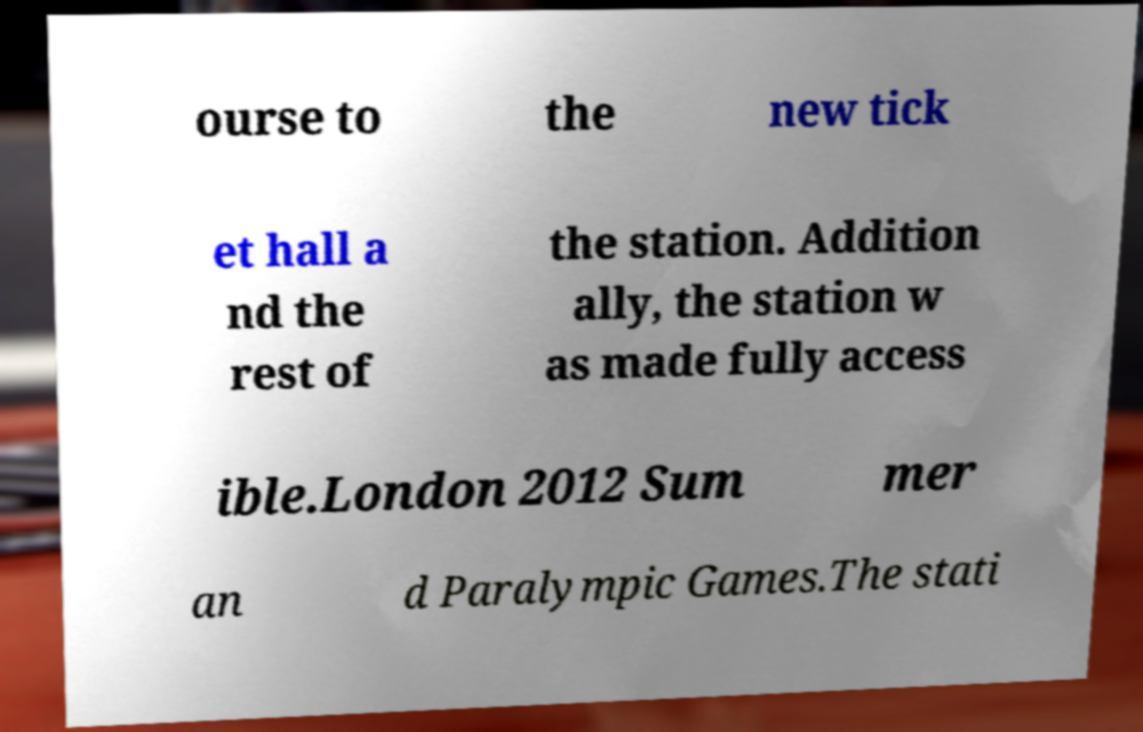Could you assist in decoding the text presented in this image and type it out clearly? ourse to the new tick et hall a nd the rest of the station. Addition ally, the station w as made fully access ible.London 2012 Sum mer an d Paralympic Games.The stati 